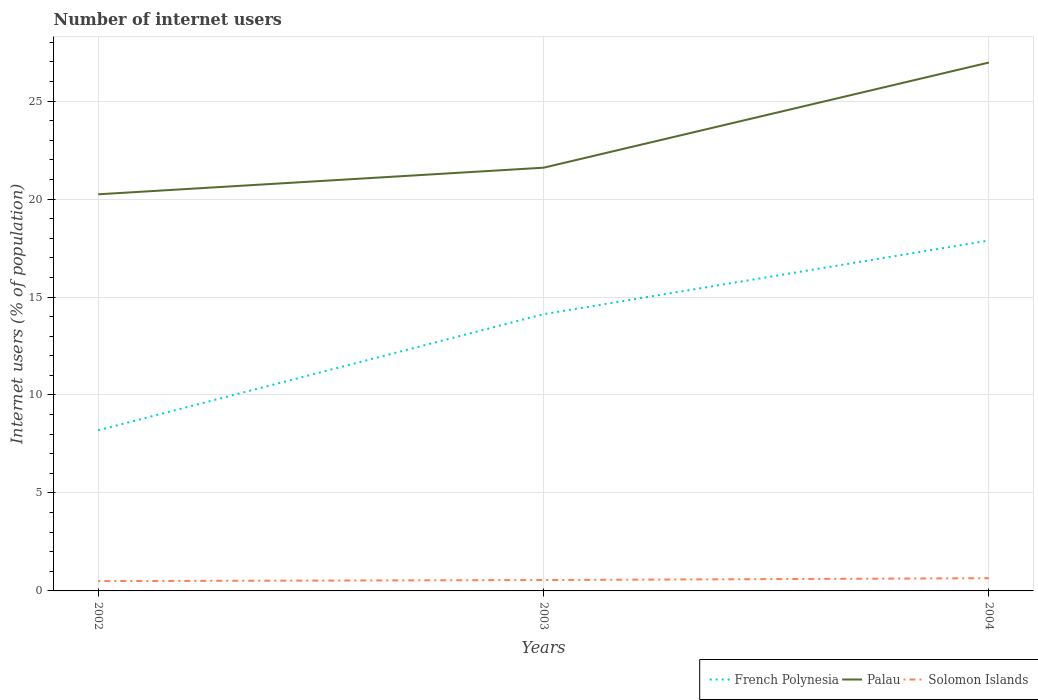Does the line corresponding to Solomon Islands intersect with the line corresponding to French Polynesia?
Provide a short and direct response. No. Is the number of lines equal to the number of legend labels?
Keep it short and to the point. Yes. Across all years, what is the maximum number of internet users in Solomon Islands?
Your response must be concise. 0.5. What is the total number of internet users in Solomon Islands in the graph?
Your answer should be very brief. -0.05. What is the difference between the highest and the second highest number of internet users in Palau?
Your answer should be very brief. 6.73. How many years are there in the graph?
Provide a short and direct response. 3. Are the values on the major ticks of Y-axis written in scientific E-notation?
Your answer should be very brief. No. What is the title of the graph?
Offer a terse response. Number of internet users. Does "Bulgaria" appear as one of the legend labels in the graph?
Keep it short and to the point. No. What is the label or title of the Y-axis?
Ensure brevity in your answer.  Internet users (% of population). What is the Internet users (% of population) in French Polynesia in 2002?
Provide a short and direct response. 8.2. What is the Internet users (% of population) in Palau in 2002?
Keep it short and to the point. 20.24. What is the Internet users (% of population) of Solomon Islands in 2002?
Make the answer very short. 0.5. What is the Internet users (% of population) in French Polynesia in 2003?
Your answer should be compact. 14.12. What is the Internet users (% of population) in Palau in 2003?
Make the answer very short. 21.6. What is the Internet users (% of population) in Solomon Islands in 2003?
Provide a succinct answer. 0.56. What is the Internet users (% of population) in French Polynesia in 2004?
Keep it short and to the point. 17.88. What is the Internet users (% of population) in Palau in 2004?
Offer a very short reply. 26.97. What is the Internet users (% of population) of Solomon Islands in 2004?
Offer a terse response. 0.65. Across all years, what is the maximum Internet users (% of population) of French Polynesia?
Offer a very short reply. 17.88. Across all years, what is the maximum Internet users (% of population) in Palau?
Offer a very short reply. 26.97. Across all years, what is the maximum Internet users (% of population) in Solomon Islands?
Keep it short and to the point. 0.65. Across all years, what is the minimum Internet users (% of population) of French Polynesia?
Give a very brief answer. 8.2. Across all years, what is the minimum Internet users (% of population) of Palau?
Offer a terse response. 20.24. Across all years, what is the minimum Internet users (% of population) in Solomon Islands?
Offer a terse response. 0.5. What is the total Internet users (% of population) of French Polynesia in the graph?
Your answer should be compact. 40.21. What is the total Internet users (% of population) in Palau in the graph?
Offer a terse response. 68.82. What is the total Internet users (% of population) in Solomon Islands in the graph?
Your response must be concise. 1.71. What is the difference between the Internet users (% of population) of French Polynesia in 2002 and that in 2003?
Your answer should be compact. -5.92. What is the difference between the Internet users (% of population) in Palau in 2002 and that in 2003?
Offer a very short reply. -1.36. What is the difference between the Internet users (% of population) of Solomon Islands in 2002 and that in 2003?
Your answer should be compact. -0.05. What is the difference between the Internet users (% of population) in French Polynesia in 2002 and that in 2004?
Offer a very short reply. -9.68. What is the difference between the Internet users (% of population) of Palau in 2002 and that in 2004?
Give a very brief answer. -6.73. What is the difference between the Internet users (% of population) in Solomon Islands in 2002 and that in 2004?
Your answer should be compact. -0.15. What is the difference between the Internet users (% of population) of French Polynesia in 2003 and that in 2004?
Provide a short and direct response. -3.76. What is the difference between the Internet users (% of population) of Palau in 2003 and that in 2004?
Keep it short and to the point. -5.37. What is the difference between the Internet users (% of population) of Solomon Islands in 2003 and that in 2004?
Provide a short and direct response. -0.09. What is the difference between the Internet users (% of population) of French Polynesia in 2002 and the Internet users (% of population) of Palau in 2003?
Your answer should be very brief. -13.4. What is the difference between the Internet users (% of population) in French Polynesia in 2002 and the Internet users (% of population) in Solomon Islands in 2003?
Offer a terse response. 7.64. What is the difference between the Internet users (% of population) of Palau in 2002 and the Internet users (% of population) of Solomon Islands in 2003?
Make the answer very short. 19.69. What is the difference between the Internet users (% of population) in French Polynesia in 2002 and the Internet users (% of population) in Palau in 2004?
Keep it short and to the point. -18.77. What is the difference between the Internet users (% of population) in French Polynesia in 2002 and the Internet users (% of population) in Solomon Islands in 2004?
Your answer should be compact. 7.55. What is the difference between the Internet users (% of population) in Palau in 2002 and the Internet users (% of population) in Solomon Islands in 2004?
Your answer should be very brief. 19.59. What is the difference between the Internet users (% of population) of French Polynesia in 2003 and the Internet users (% of population) of Palau in 2004?
Make the answer very short. -12.85. What is the difference between the Internet users (% of population) of French Polynesia in 2003 and the Internet users (% of population) of Solomon Islands in 2004?
Your answer should be very brief. 13.47. What is the difference between the Internet users (% of population) in Palau in 2003 and the Internet users (% of population) in Solomon Islands in 2004?
Keep it short and to the point. 20.95. What is the average Internet users (% of population) in French Polynesia per year?
Your response must be concise. 13.4. What is the average Internet users (% of population) of Palau per year?
Offer a terse response. 22.94. What is the average Internet users (% of population) in Solomon Islands per year?
Ensure brevity in your answer.  0.57. In the year 2002, what is the difference between the Internet users (% of population) in French Polynesia and Internet users (% of population) in Palau?
Provide a succinct answer. -12.04. In the year 2002, what is the difference between the Internet users (% of population) of French Polynesia and Internet users (% of population) of Solomon Islands?
Provide a short and direct response. 7.7. In the year 2002, what is the difference between the Internet users (% of population) in Palau and Internet users (% of population) in Solomon Islands?
Your answer should be compact. 19.74. In the year 2003, what is the difference between the Internet users (% of population) of French Polynesia and Internet users (% of population) of Palau?
Give a very brief answer. -7.48. In the year 2003, what is the difference between the Internet users (% of population) in French Polynesia and Internet users (% of population) in Solomon Islands?
Provide a succinct answer. 13.57. In the year 2003, what is the difference between the Internet users (% of population) of Palau and Internet users (% of population) of Solomon Islands?
Give a very brief answer. 21.05. In the year 2004, what is the difference between the Internet users (% of population) in French Polynesia and Internet users (% of population) in Palau?
Keep it short and to the point. -9.09. In the year 2004, what is the difference between the Internet users (% of population) in French Polynesia and Internet users (% of population) in Solomon Islands?
Provide a short and direct response. 17.23. In the year 2004, what is the difference between the Internet users (% of population) in Palau and Internet users (% of population) in Solomon Islands?
Make the answer very short. 26.32. What is the ratio of the Internet users (% of population) in French Polynesia in 2002 to that in 2003?
Provide a succinct answer. 0.58. What is the ratio of the Internet users (% of population) of Palau in 2002 to that in 2003?
Offer a very short reply. 0.94. What is the ratio of the Internet users (% of population) in Solomon Islands in 2002 to that in 2003?
Your response must be concise. 0.9. What is the ratio of the Internet users (% of population) of French Polynesia in 2002 to that in 2004?
Ensure brevity in your answer.  0.46. What is the ratio of the Internet users (% of population) in Palau in 2002 to that in 2004?
Offer a very short reply. 0.75. What is the ratio of the Internet users (% of population) in Solomon Islands in 2002 to that in 2004?
Your answer should be very brief. 0.77. What is the ratio of the Internet users (% of population) of French Polynesia in 2003 to that in 2004?
Give a very brief answer. 0.79. What is the ratio of the Internet users (% of population) of Palau in 2003 to that in 2004?
Your answer should be compact. 0.8. What is the ratio of the Internet users (% of population) of Solomon Islands in 2003 to that in 2004?
Ensure brevity in your answer.  0.86. What is the difference between the highest and the second highest Internet users (% of population) in French Polynesia?
Ensure brevity in your answer.  3.76. What is the difference between the highest and the second highest Internet users (% of population) in Palau?
Ensure brevity in your answer.  5.37. What is the difference between the highest and the second highest Internet users (% of population) of Solomon Islands?
Provide a succinct answer. 0.09. What is the difference between the highest and the lowest Internet users (% of population) of French Polynesia?
Your response must be concise. 9.68. What is the difference between the highest and the lowest Internet users (% of population) of Palau?
Offer a terse response. 6.73. What is the difference between the highest and the lowest Internet users (% of population) in Solomon Islands?
Offer a terse response. 0.15. 